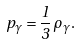Convert formula to latex. <formula><loc_0><loc_0><loc_500><loc_500>p _ { \gamma } = \frac { 1 } { 3 } \, \rho _ { \gamma } .</formula> 